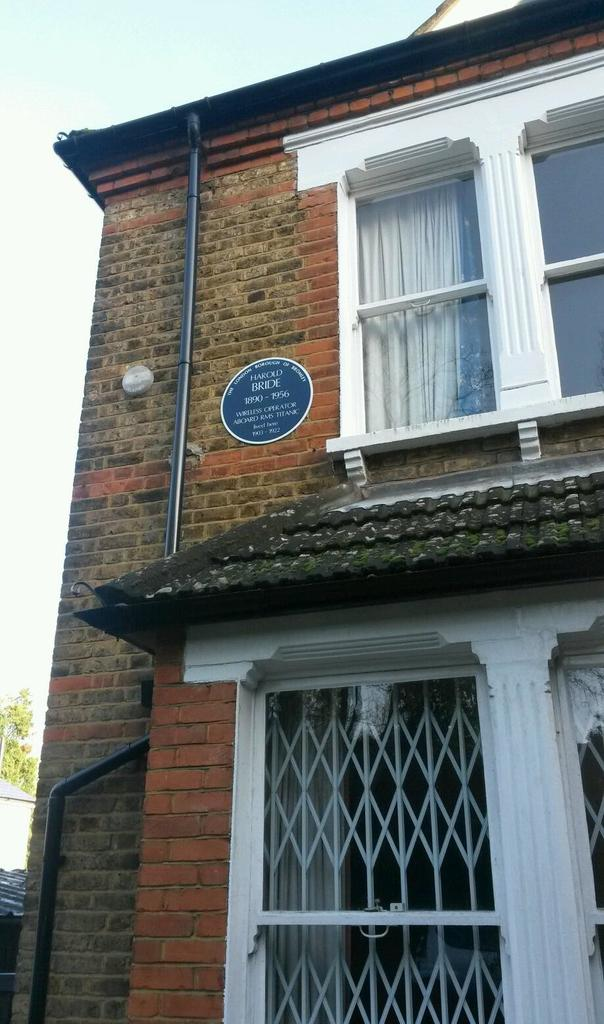What structure is located on the right side of the image? There is a building on the right side of the image. What is visible at the top of the image? The sky is visible at the top of the image. What type of vegetation is on the left side of the image? There is a tree on the left side of the image. What type of committee can be seen discussing the feast in the image? There is no committee or feast present in the image; it features a building, sky, and a tree. What part of the building is hosting the part in the image? There is no part or indication of a party happening in the image. 